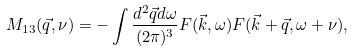<formula> <loc_0><loc_0><loc_500><loc_500>M _ { 1 3 } ( \vec { q } , \nu ) = - \int \frac { d ^ { 2 } \vec { q } d \omega } { ( 2 \pi ) ^ { 3 } } F ( \vec { k } , \omega ) F ( \vec { k } + \vec { q } , \omega + \nu ) ,</formula> 